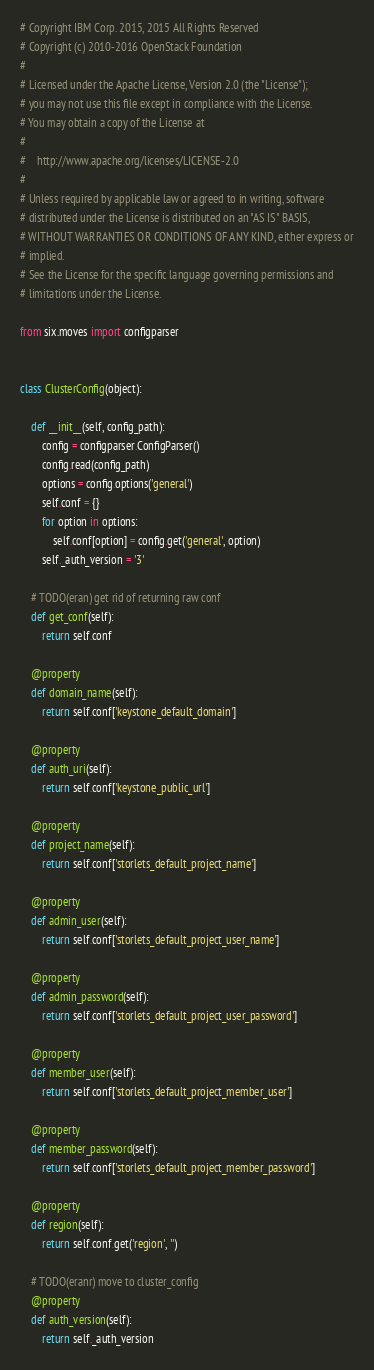Convert code to text. <code><loc_0><loc_0><loc_500><loc_500><_Python_># Copyright IBM Corp. 2015, 2015 All Rights Reserved
# Copyright (c) 2010-2016 OpenStack Foundation
#
# Licensed under the Apache License, Version 2.0 (the "License");
# you may not use this file except in compliance with the License.
# You may obtain a copy of the License at
#
#    http://www.apache.org/licenses/LICENSE-2.0
#
# Unless required by applicable law or agreed to in writing, software
# distributed under the License is distributed on an "AS IS" BASIS,
# WITHOUT WARRANTIES OR CONDITIONS OF ANY KIND, either express or
# implied.
# See the License for the specific language governing permissions and
# limitations under the License.

from six.moves import configparser


class ClusterConfig(object):

    def __init__(self, config_path):
        config = configparser.ConfigParser()
        config.read(config_path)
        options = config.options('general')
        self.conf = {}
        for option in options:
            self.conf[option] = config.get('general', option)
        self._auth_version = '3'

    # TODO(eran) get rid of returning raw conf
    def get_conf(self):
        return self.conf

    @property
    def domain_name(self):
        return self.conf['keystone_default_domain']

    @property
    def auth_uri(self):
        return self.conf['keystone_public_url']

    @property
    def project_name(self):
        return self.conf['storlets_default_project_name']

    @property
    def admin_user(self):
        return self.conf['storlets_default_project_user_name']

    @property
    def admin_password(self):
        return self.conf['storlets_default_project_user_password']

    @property
    def member_user(self):
        return self.conf['storlets_default_project_member_user']

    @property
    def member_password(self):
        return self.conf['storlets_default_project_member_password']

    @property
    def region(self):
        return self.conf.get('region', '')

    # TODO(eranr) move to cluster_config
    @property
    def auth_version(self):
        return self._auth_version
</code> 